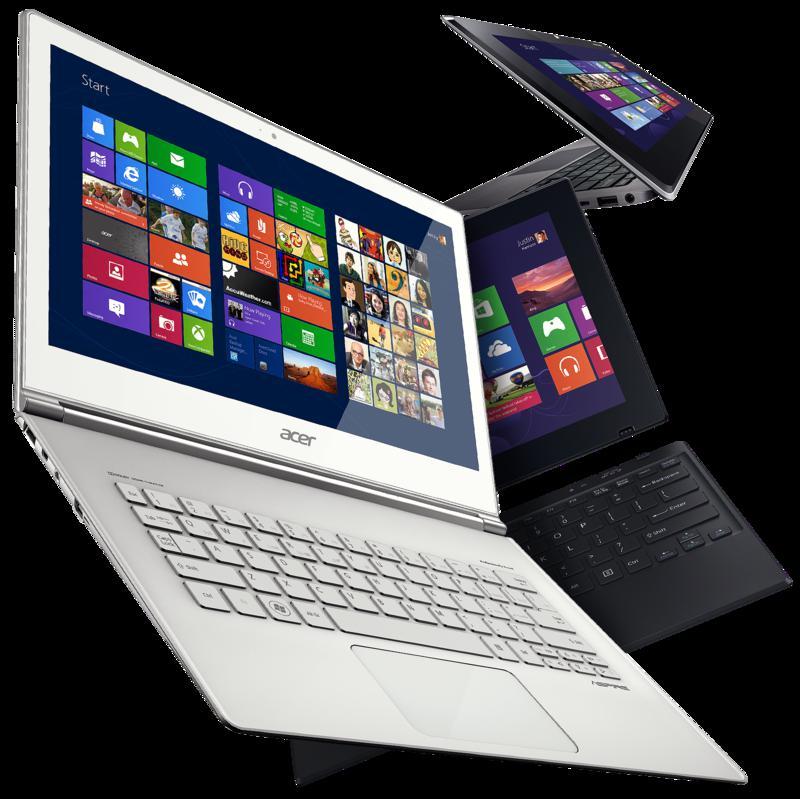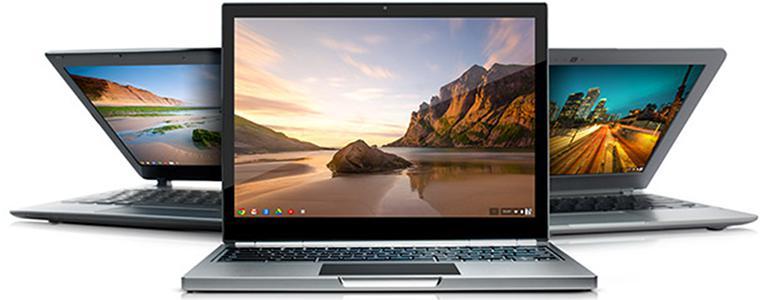The first image is the image on the left, the second image is the image on the right. Examine the images to the left and right. Is the description "The right image features three opened laptops." accurate? Answer yes or no. Yes. The first image is the image on the left, the second image is the image on the right. Examine the images to the left and right. Is the description "The right image depicts three laptops." accurate? Answer yes or no. Yes. 